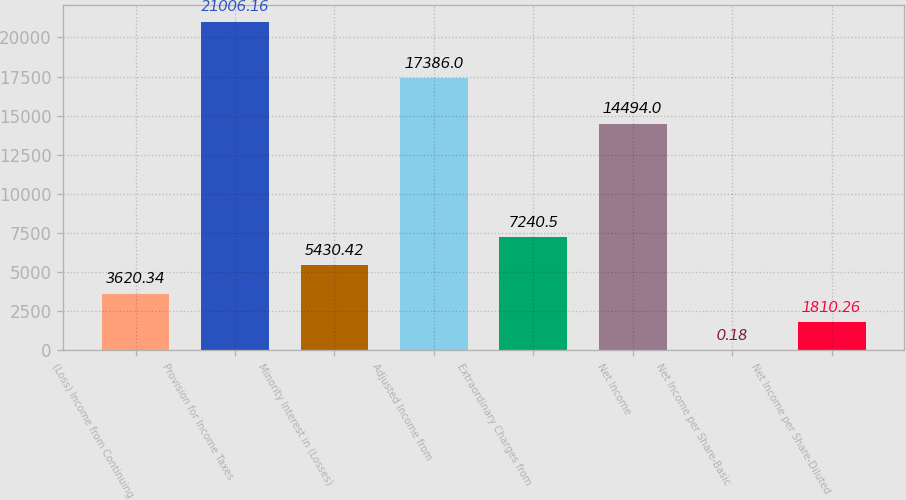Convert chart. <chart><loc_0><loc_0><loc_500><loc_500><bar_chart><fcel>(Loss) Income from Continuing<fcel>Provision for Income Taxes<fcel>Minority Interest in (Losses)<fcel>Adjusted Income from<fcel>Extraordinary Charges from<fcel>Net Income<fcel>Net Income per Share-Basic<fcel>Net Income per Share-Diluted<nl><fcel>3620.34<fcel>21006.2<fcel>5430.42<fcel>17386<fcel>7240.5<fcel>14494<fcel>0.18<fcel>1810.26<nl></chart> 